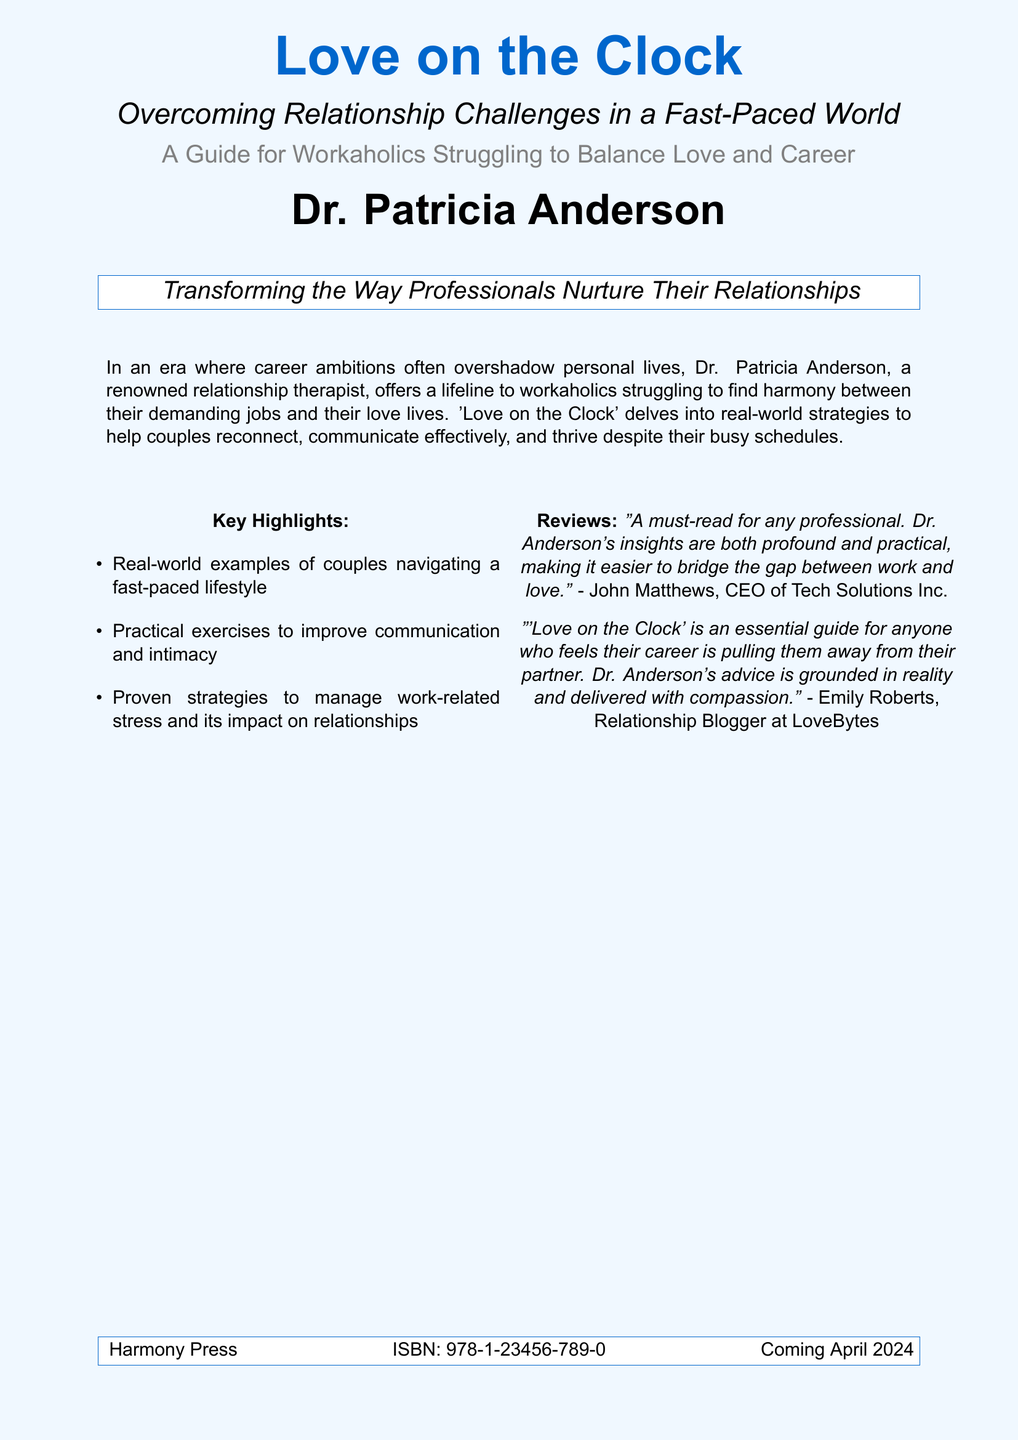What is the title of the book? The title is prominently displayed on the cover in a large font.
Answer: Love on the Clock Who is the author of the book? The author's name is listed at the bottom of the cover.
Answer: Dr. Patricia Anderson What is the book's ISBN? The ISBN is provided towards the bottom of the cover.
Answer: 978-1-23456-789-0 What type of professionals is the book aimed at? The subtitle indicates the target audience for the book.
Answer: Workaholics What does the book aim to transform? The description mentions the focus of the book regarding relationships.
Answer: The Way Professionals Nurture Their Relationships When is the book coming out? The release date is included at the bottom of the cover.
Answer: April 2024 What is the name of the publishing company? The publishing company is mentioned in the footer.
Answer: Harmony Press What is one of the key highlights mentioned in the book? The highlights section lists various benefits of reading the book.
Answer: Real-world examples of couples navigating a fast-paced lifestyle How does Dr. Anderson describe her advice? A review on the cover characterizes the advice given in the book.
Answer: Grounded in reality and delivered with compassion 